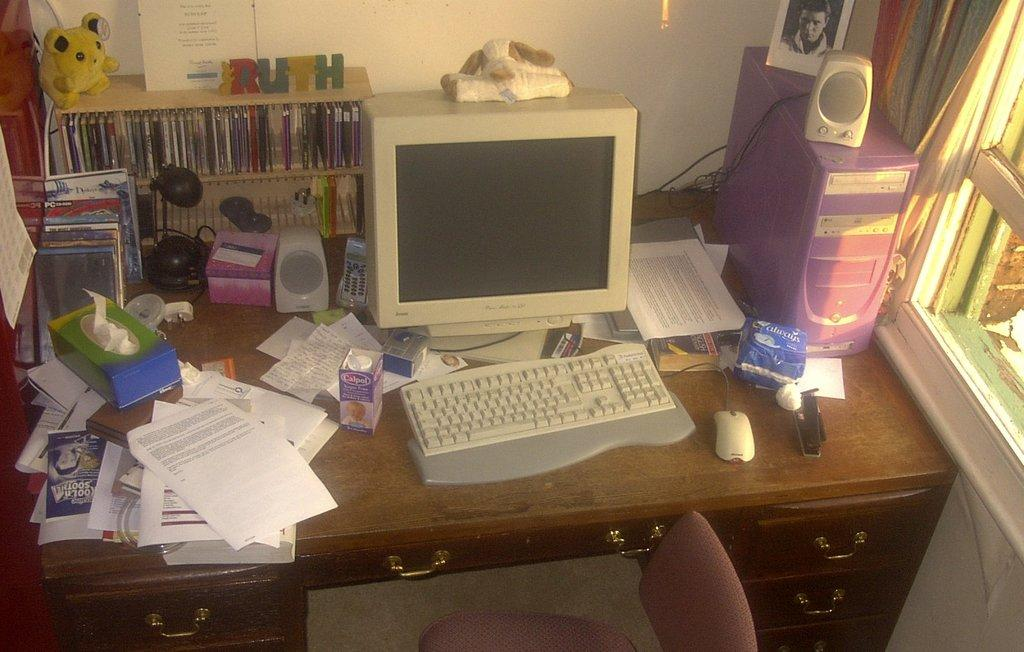<image>
Summarize the visual content of the image. A messy computer desk with a box of Calpol init 